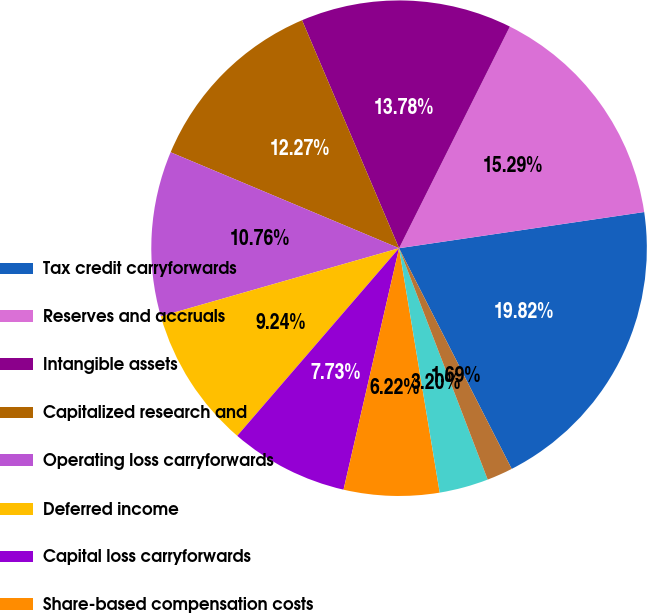Convert chart to OTSL. <chart><loc_0><loc_0><loc_500><loc_500><pie_chart><fcel>Tax credit carryforwards<fcel>Reserves and accruals<fcel>Intangible assets<fcel>Capitalized research and<fcel>Operating loss carryforwards<fcel>Deferred income<fcel>Capital loss carryforwards<fcel>Share-based compensation costs<fcel>Depreciation and amortization<fcel>Investments<nl><fcel>19.82%<fcel>15.29%<fcel>13.78%<fcel>12.27%<fcel>10.76%<fcel>9.24%<fcel>7.73%<fcel>6.22%<fcel>3.2%<fcel>1.69%<nl></chart> 